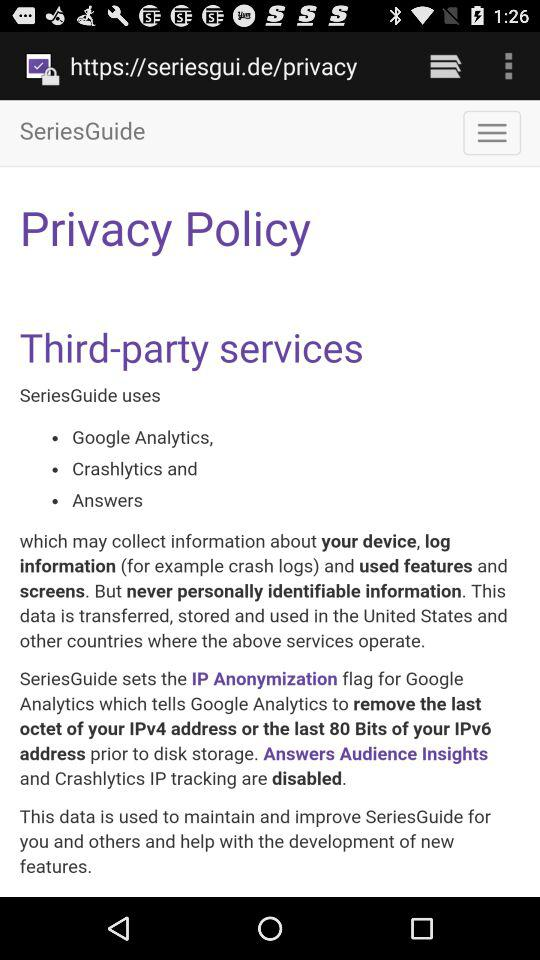How many services does SeriesGuide use that collect information about your device?
Answer the question using a single word or phrase. 3 